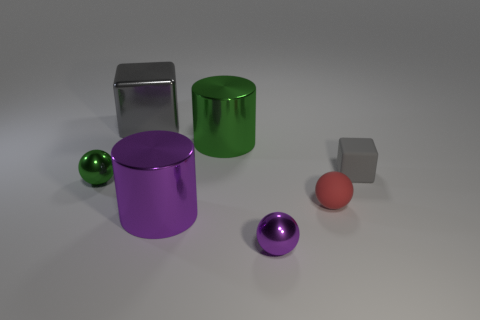Subtract all green metal balls. How many balls are left? 2 Subtract all balls. How many objects are left? 4 Subtract 1 spheres. How many spheres are left? 2 Subtract all red spheres. How many spheres are left? 2 Add 2 tiny cyan metal blocks. How many objects exist? 9 Subtract 0 yellow cylinders. How many objects are left? 7 Subtract all cyan blocks. Subtract all cyan balls. How many blocks are left? 2 Subtract all yellow cylinders. How many red blocks are left? 0 Subtract all big red blocks. Subtract all green metal spheres. How many objects are left? 6 Add 6 metallic cubes. How many metallic cubes are left? 7 